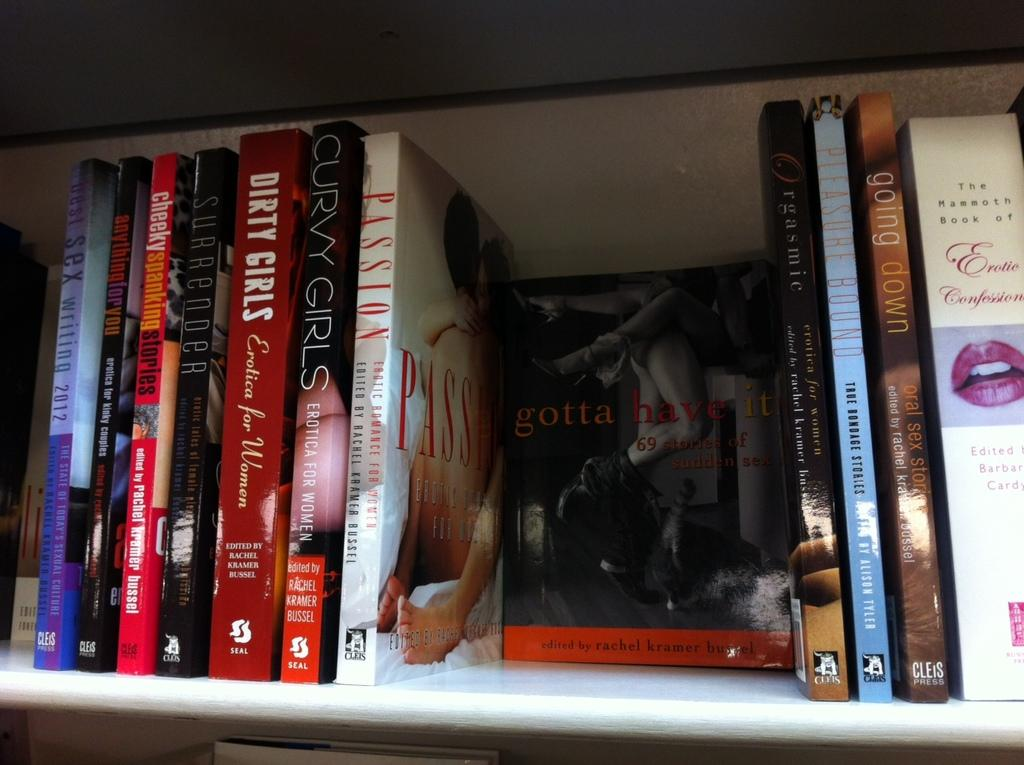<image>
Present a compact description of the photo's key features. some books entitled DIRTY GIRLS, CURVY GIRLS, PASSION, gotta have it, going down and more. 